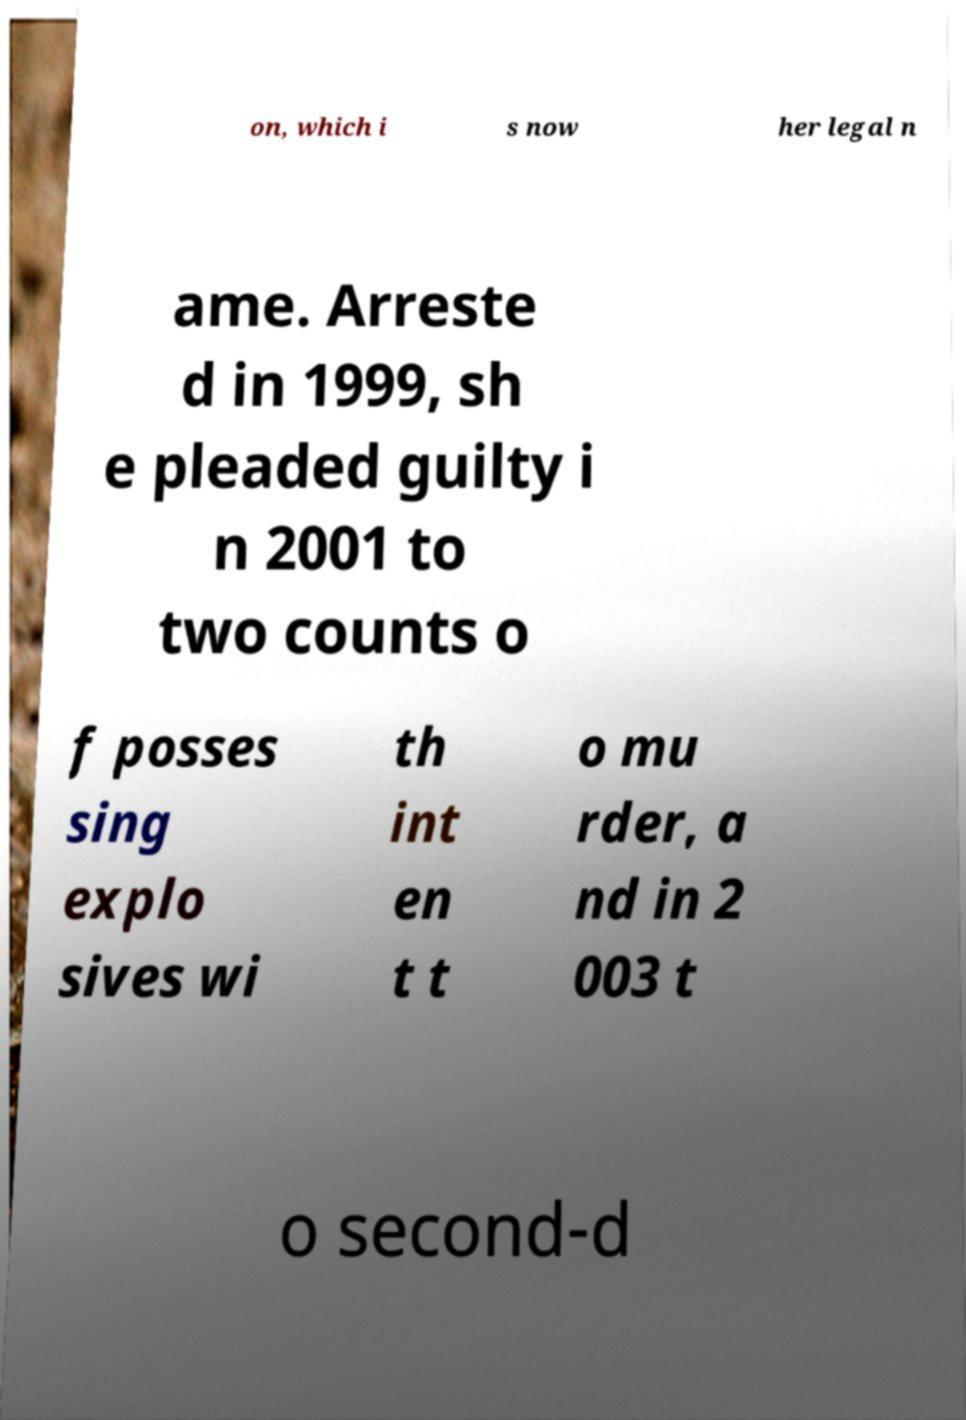What messages or text are displayed in this image? I need them in a readable, typed format. on, which i s now her legal n ame. Arreste d in 1999, sh e pleaded guilty i n 2001 to two counts o f posses sing explo sives wi th int en t t o mu rder, a nd in 2 003 t o second-d 